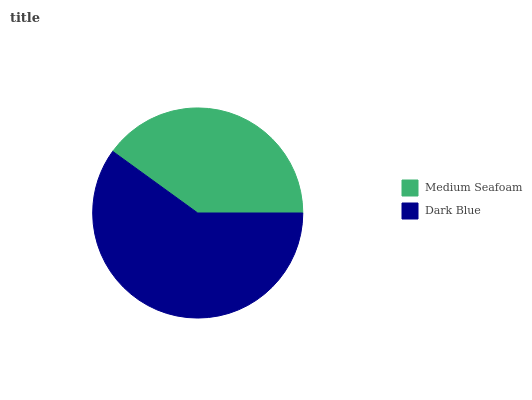Is Medium Seafoam the minimum?
Answer yes or no. Yes. Is Dark Blue the maximum?
Answer yes or no. Yes. Is Dark Blue the minimum?
Answer yes or no. No. Is Dark Blue greater than Medium Seafoam?
Answer yes or no. Yes. Is Medium Seafoam less than Dark Blue?
Answer yes or no. Yes. Is Medium Seafoam greater than Dark Blue?
Answer yes or no. No. Is Dark Blue less than Medium Seafoam?
Answer yes or no. No. Is Dark Blue the high median?
Answer yes or no. Yes. Is Medium Seafoam the low median?
Answer yes or no. Yes. Is Medium Seafoam the high median?
Answer yes or no. No. Is Dark Blue the low median?
Answer yes or no. No. 